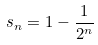Convert formula to latex. <formula><loc_0><loc_0><loc_500><loc_500>s _ { n } = 1 - \frac { 1 } { 2 ^ { n } }</formula> 